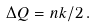Convert formula to latex. <formula><loc_0><loc_0><loc_500><loc_500>\Delta Q = n k / 2 \, .</formula> 